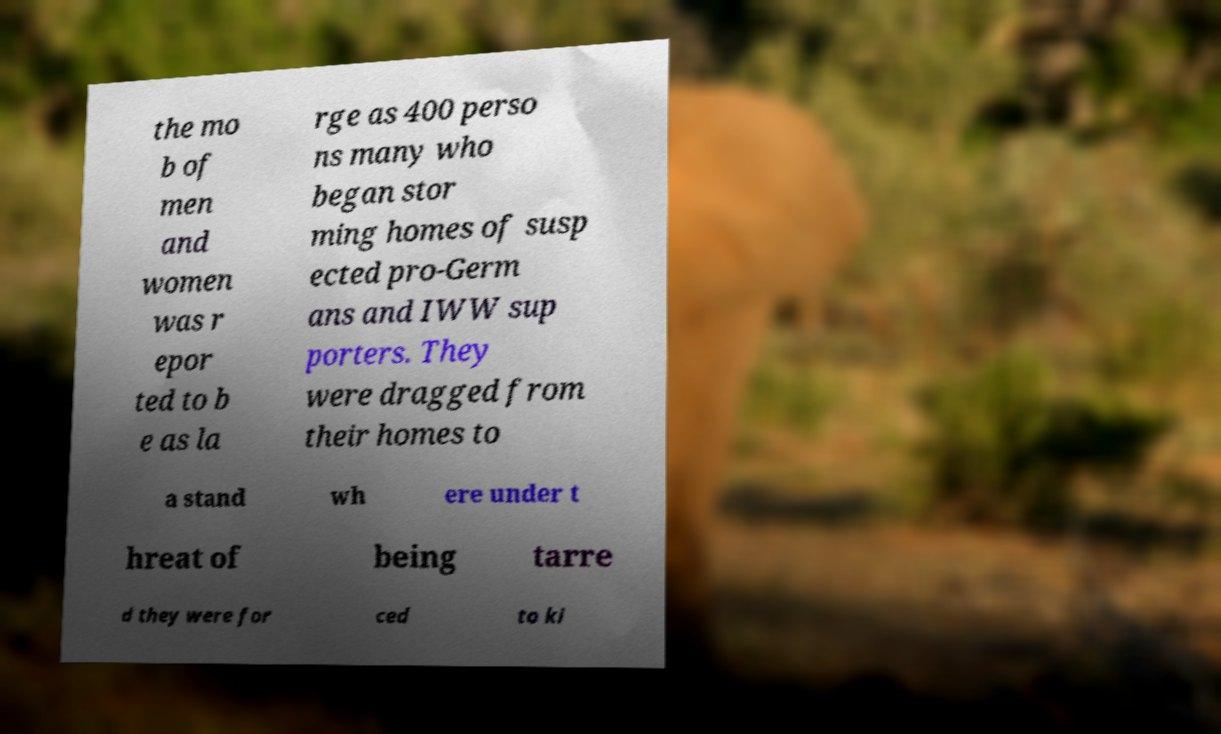Can you read and provide the text displayed in the image?This photo seems to have some interesting text. Can you extract and type it out for me? the mo b of men and women was r epor ted to b e as la rge as 400 perso ns many who began stor ming homes of susp ected pro-Germ ans and IWW sup porters. They were dragged from their homes to a stand wh ere under t hreat of being tarre d they were for ced to ki 